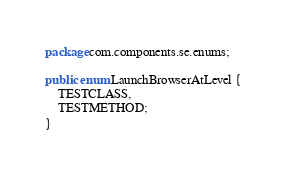Convert code to text. <code><loc_0><loc_0><loc_500><loc_500><_Java_>package com.components.se.enums;

public enum LaunchBrowserAtLevel {
	TESTCLASS,
	TESTMETHOD;
}
</code> 